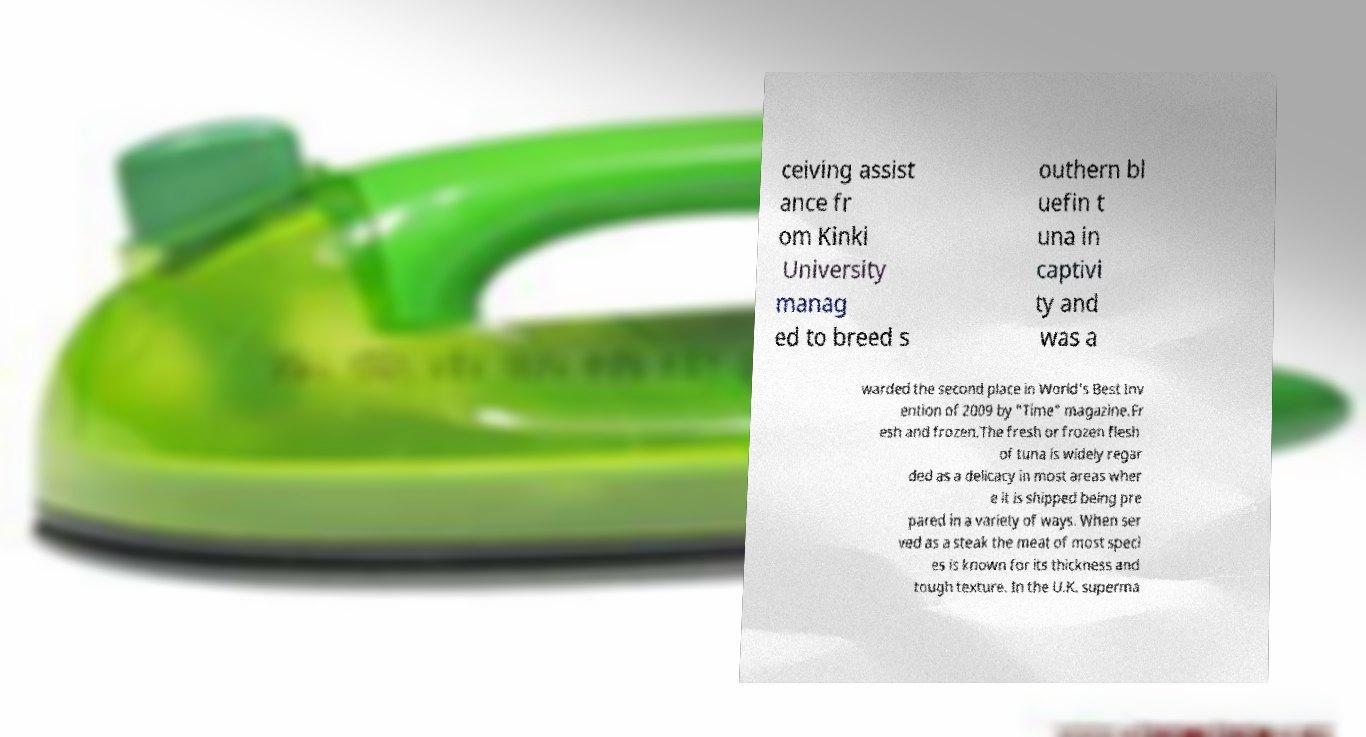For documentation purposes, I need the text within this image transcribed. Could you provide that? ceiving assist ance fr om Kinki University manag ed to breed s outhern bl uefin t una in captivi ty and was a warded the second place in World's Best Inv ention of 2009 by "Time" magazine.Fr esh and frozen.The fresh or frozen flesh of tuna is widely regar ded as a delicacy in most areas wher e it is shipped being pre pared in a variety of ways. When ser ved as a steak the meat of most speci es is known for its thickness and tough texture. In the U.K. superma 